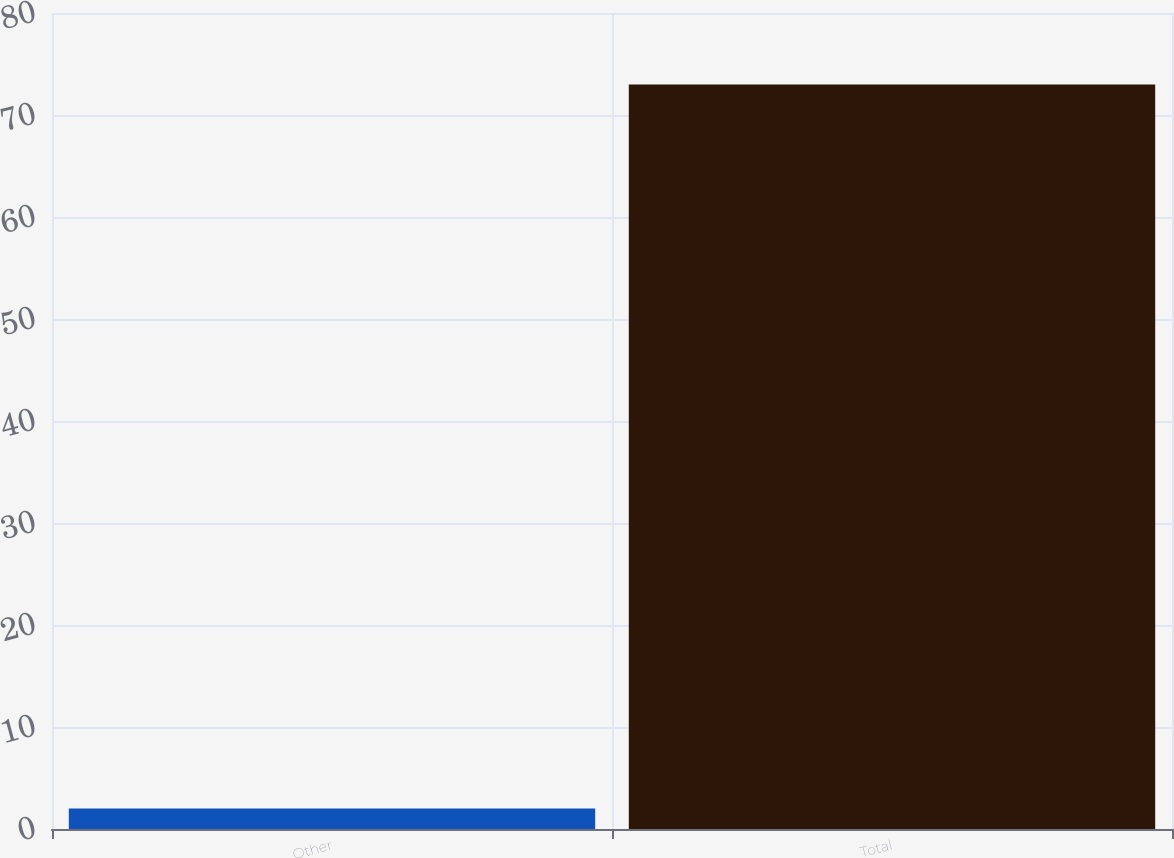Convert chart. <chart><loc_0><loc_0><loc_500><loc_500><bar_chart><fcel>Other<fcel>Total<nl><fcel>2<fcel>73<nl></chart> 